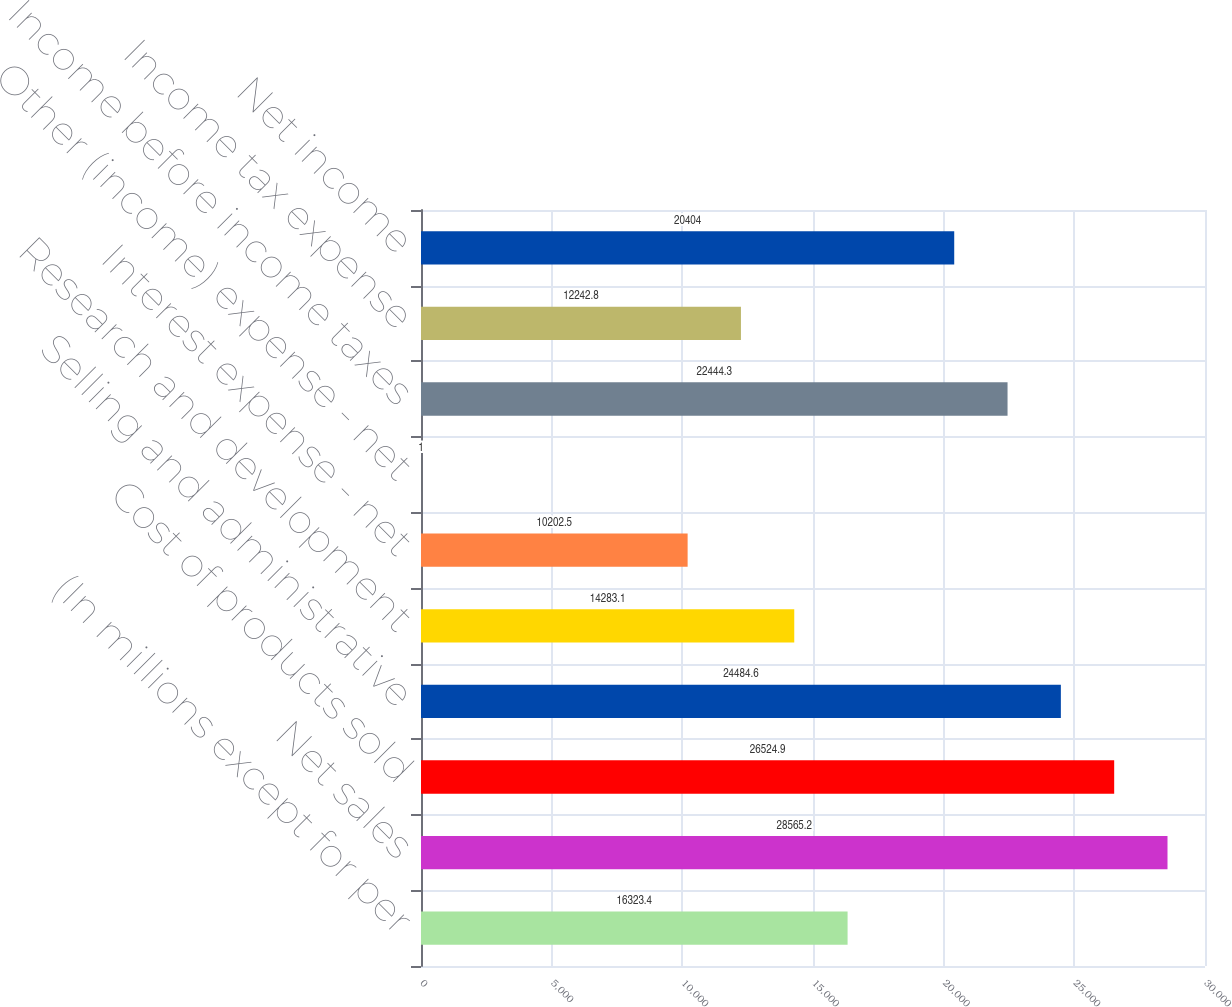Convert chart to OTSL. <chart><loc_0><loc_0><loc_500><loc_500><bar_chart><fcel>(In millions except for per<fcel>Net sales<fcel>Cost of products sold<fcel>Selling and administrative<fcel>Research and development<fcel>Interest expense - net<fcel>Other (income) expense - net<fcel>Income before income taxes<fcel>Income tax expense<fcel>Net income<nl><fcel>16323.4<fcel>28565.2<fcel>26524.9<fcel>24484.6<fcel>14283.1<fcel>10202.5<fcel>1<fcel>22444.3<fcel>12242.8<fcel>20404<nl></chart> 